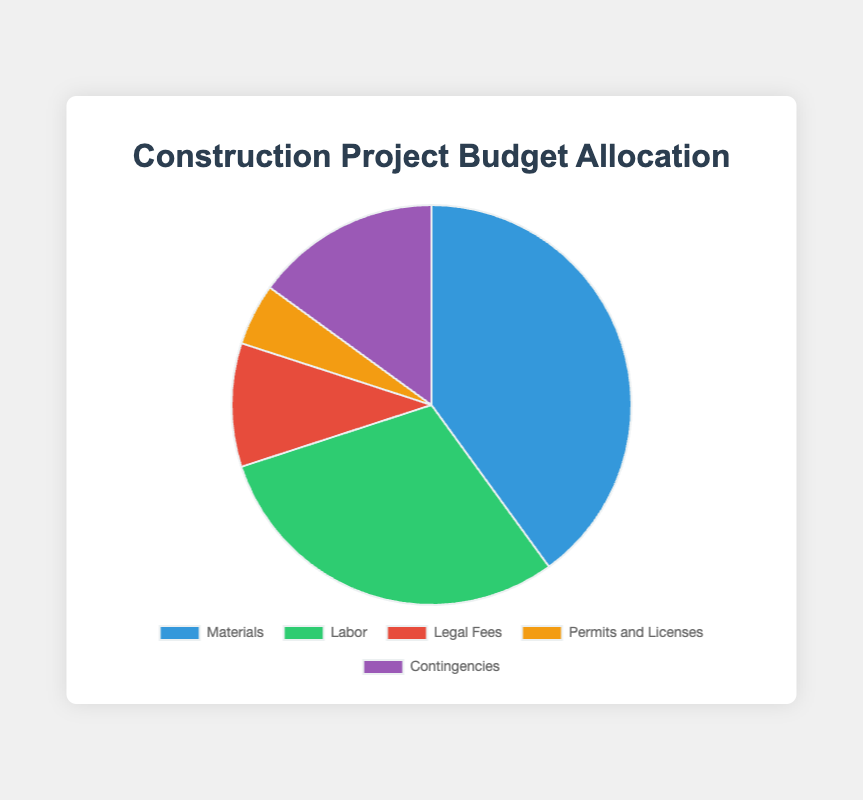what percentage of the budget is allocated to contingencies? The pie chart shows that contingencies comprise 15% of the construction project budget.
Answer: 15% which two categories together constitute half of the budget? Materials (40%) and Labor (30%) together make up 70% of the budget, which is more than half. To find exactly half, 50%, we need to combine 40% (Materials) and 10% (Legal Fees), summing to exactly 50%.
Answer: Materials and Legal Fees how much more is allocated to materials compared to legal fees? Materials make up 40% of the budget, whereas Legal Fees represent 10%. The difference is 40% - 10% = 30%.
Answer: 30% what is the combined percentage of the budget for permits and licenses and contingencies? Permits and Licenses constitute 5% of the budget, and Contingencies make up 15%. Summing these gives 5% + 15% = 20%.
Answer: 20% which category has the smallest allocation, and what percentage is it? The category with the smallest allocation is Permits and Licenses, which makes up 5% of the budget.
Answer: Permits and Licenses, 5% is the allocation for labor greater than materials, contingencies, and legal fees combined? Labor is 30% of the budget. Combining Materials (40%), Contingencies (15%), and Legal Fees (10%) gives 40% + 15% + 10% = 65%, which is greater than the allocation for labor.
Answer: No what is the difference in the budget allocations between the largest and smallest categories? The largest category is Materials at 40%. The smallest category is Permits and Licenses at 5%. The difference is 40% - 5% = 35%.
Answer: 35% how does the budget allocation for legal fees compare to that for contingencies? Legal Fees account for 10% of the budget, whereas Contingencies are 15%. Legal Fees are less than Contingencies by 15% - 10% = 5%.
Answer: Less, by 5% if the budget for legal fees doubled, what percentage of the total budget would it then represent? The current allocation for Legal Fees is 10%. If it doubled, it would be 10% * 2 = 20%.
Answer: 20% what is the average budget allocation across all categories? The total percentage of all categories is 100%. There are 5 categories. The average allocation is 100% / 5 = 20%.
Answer: 20% 